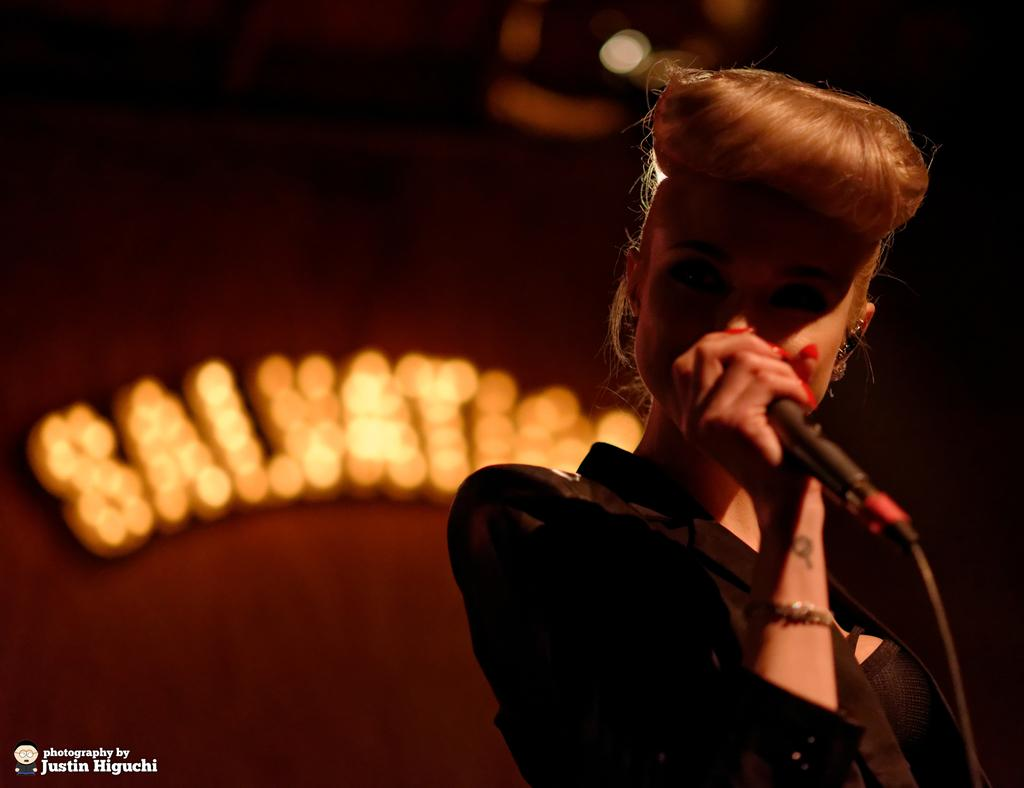Who is the main subject in the image? There is a woman in the image. What is the woman holding in the image? The woman is holding a microphone. What can be seen on the wall in the background? There is text on a wall in the background. What type of lighting is visible in the background? There are lights visible in the background. What type of laborer is working on the edge of the image? There is no laborer or edge present in the image. How does the woman's digestion affect her performance in the image? There is no information about the woman's digestion in the image, and it is not relevant to her performance. 